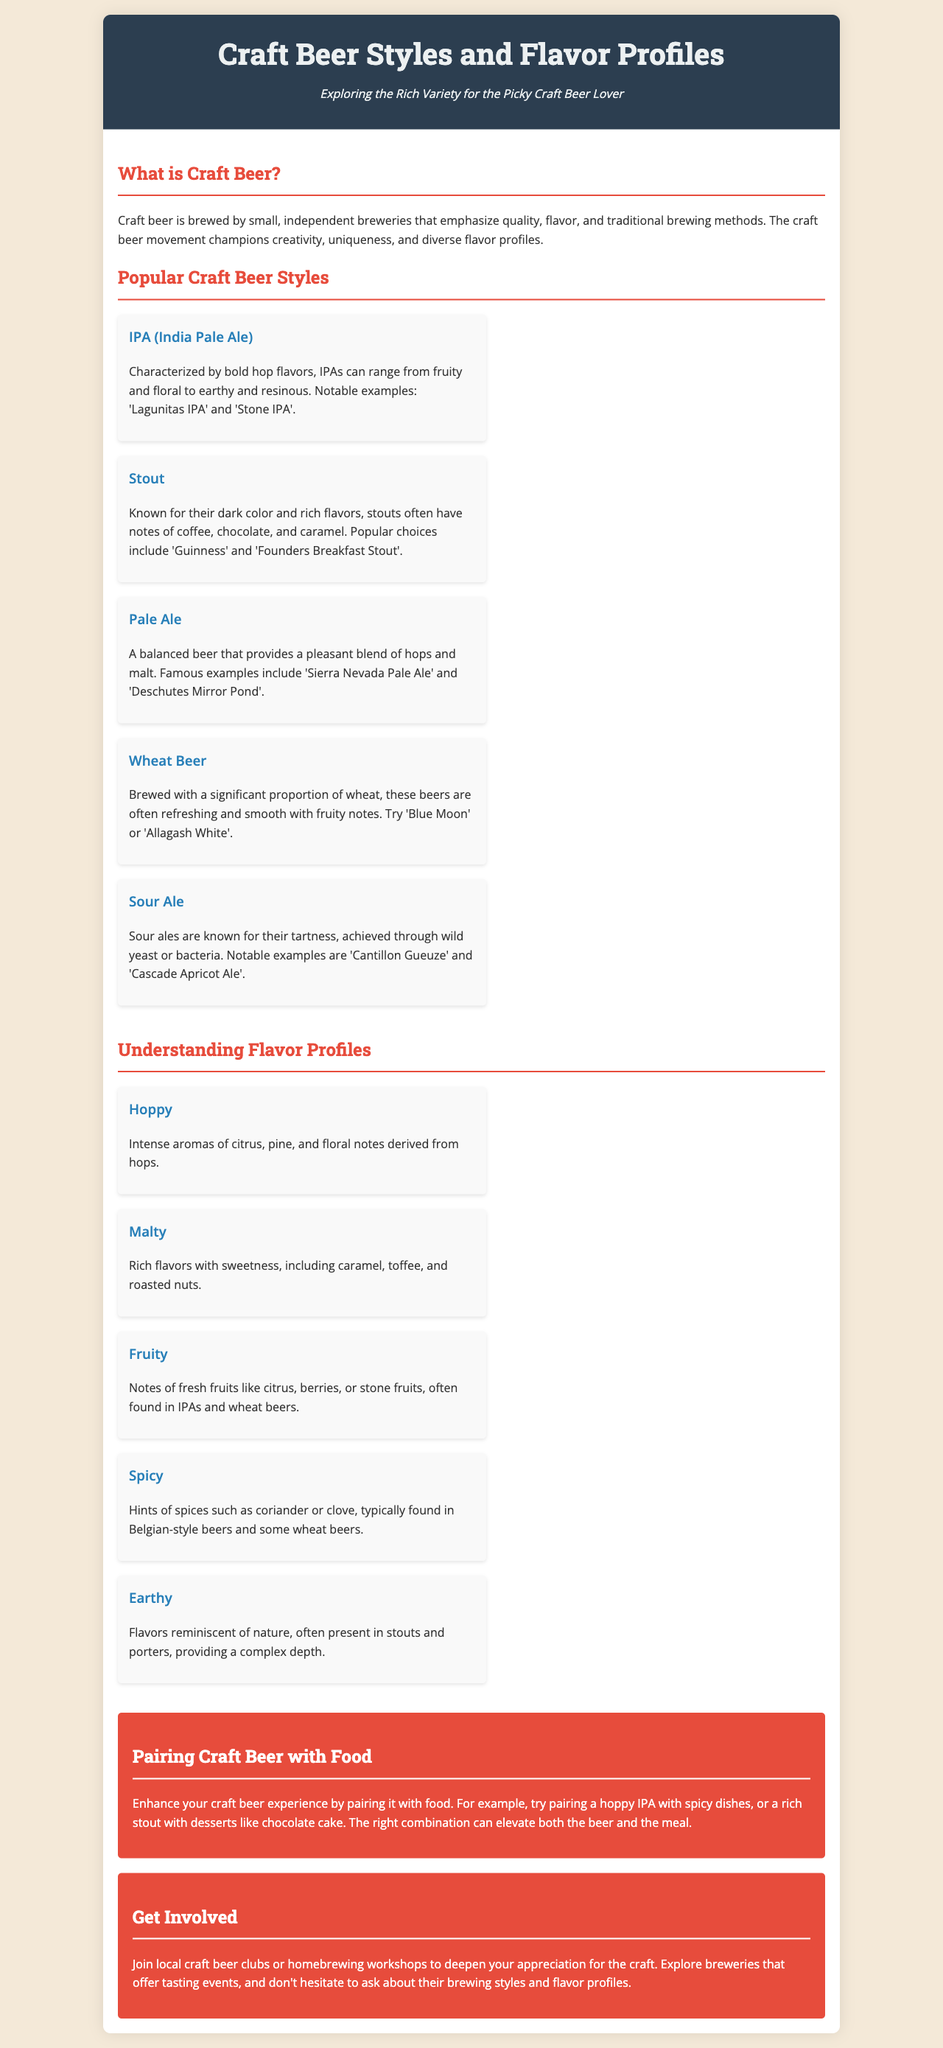What is craft beer? Craft beer is brewed by small, independent breweries that emphasize quality, flavor, and traditional brewing methods.
Answer: Brewed by small, independent breweries What style of beer is characterized by bold hop flavors? The document describes that IPAs can range from fruity and floral to earthy and resinous, characterized by bold hop flavors.
Answer: IPA (India Pale Ale) Name a notable example of a stout. The document provides popular choices for stouts, including famous brands.
Answer: Guinness What flavor profile has intense aromas of citrus, pine, and floral notes? The document explains that "hoppy" flavor profiles feature these characteristics.
Answer: Hoppy Which beer style is known for their tartness? Sour ales are identified in the document as being known for their tartness.
Answer: Sour Ale Which beer style would pair well with spicy dishes? The document suggests hoppy IPAs as a good pairing for spicy dishes.
Answer: Hoppy IPA What are the key flavors associated with malty profiles? The document mentions rich flavors with sweetness, including caramel, toffee, and roasted nuts are key to malty profiles.
Answer: Caramel, toffee, roasted nuts How can one enhance their craft beer experience? The document advises pairing craft beer with different foods to elevate both beer and meal.
Answer: Pairing with food What does the document suggest for getting involved in the craft beer community? The document encourages joining local craft beer clubs or homebrewing workshops to enhance appreciation.
Answer: Join local craft beer clubs or workshops 